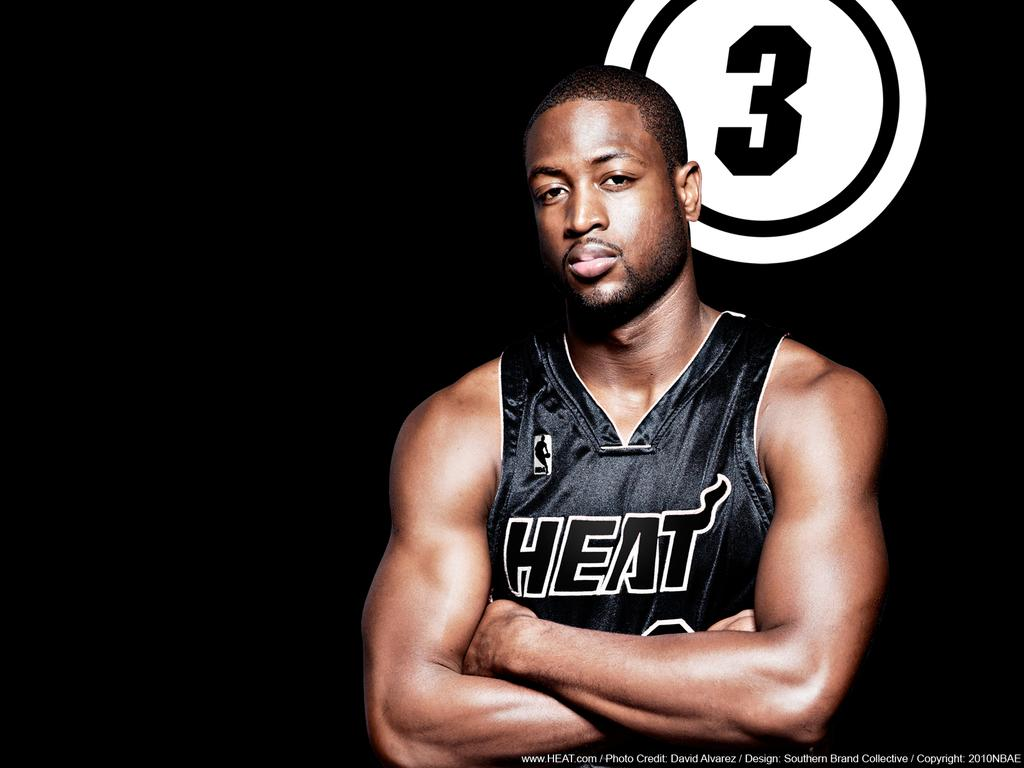<image>
Present a compact description of the photo's key features. A man is wearing a sleeveless sports shirt with HEAT on it and #3 is in the back of him. 